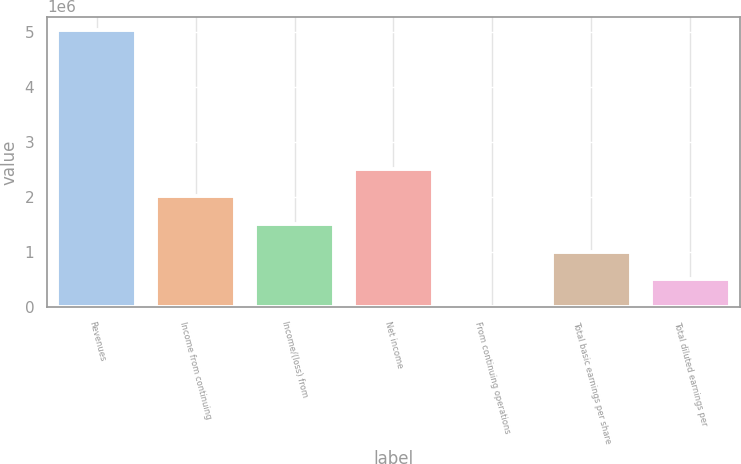<chart> <loc_0><loc_0><loc_500><loc_500><bar_chart><fcel>Revenues<fcel>Income from continuing<fcel>Income/(loss) from<fcel>Net income<fcel>From continuing operations<fcel>Total basic earnings per share<fcel>Total diluted earnings per<nl><fcel>5.02242e+06<fcel>2.00897e+06<fcel>1.50673e+06<fcel>2.51121e+06<fcel>3.81<fcel>1.00449e+06<fcel>502245<nl></chart> 